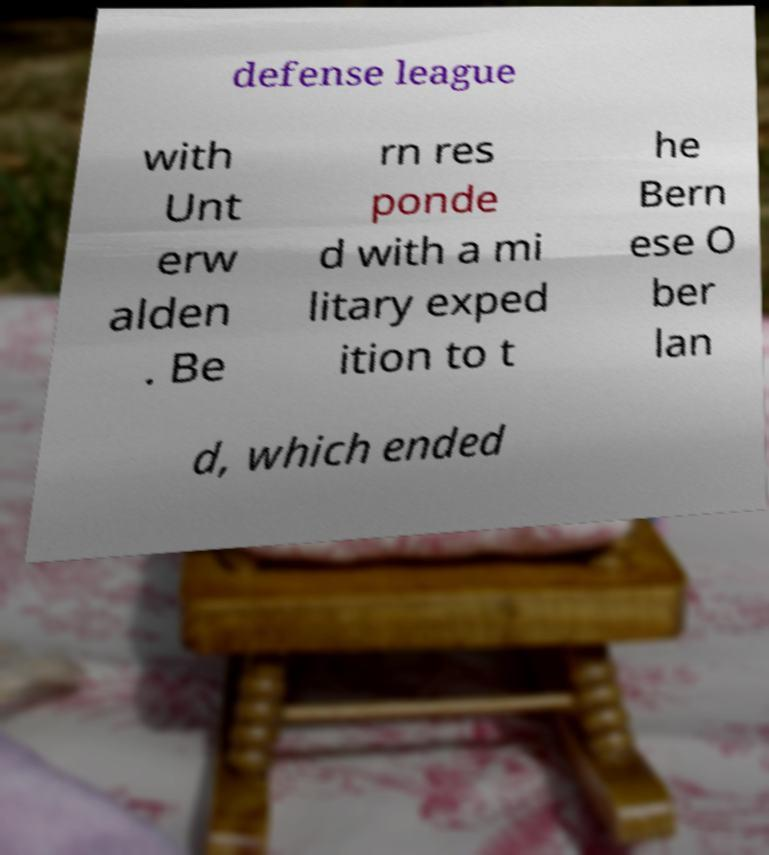Could you assist in decoding the text presented in this image and type it out clearly? defense league with Unt erw alden . Be rn res ponde d with a mi litary exped ition to t he Bern ese O ber lan d, which ended 